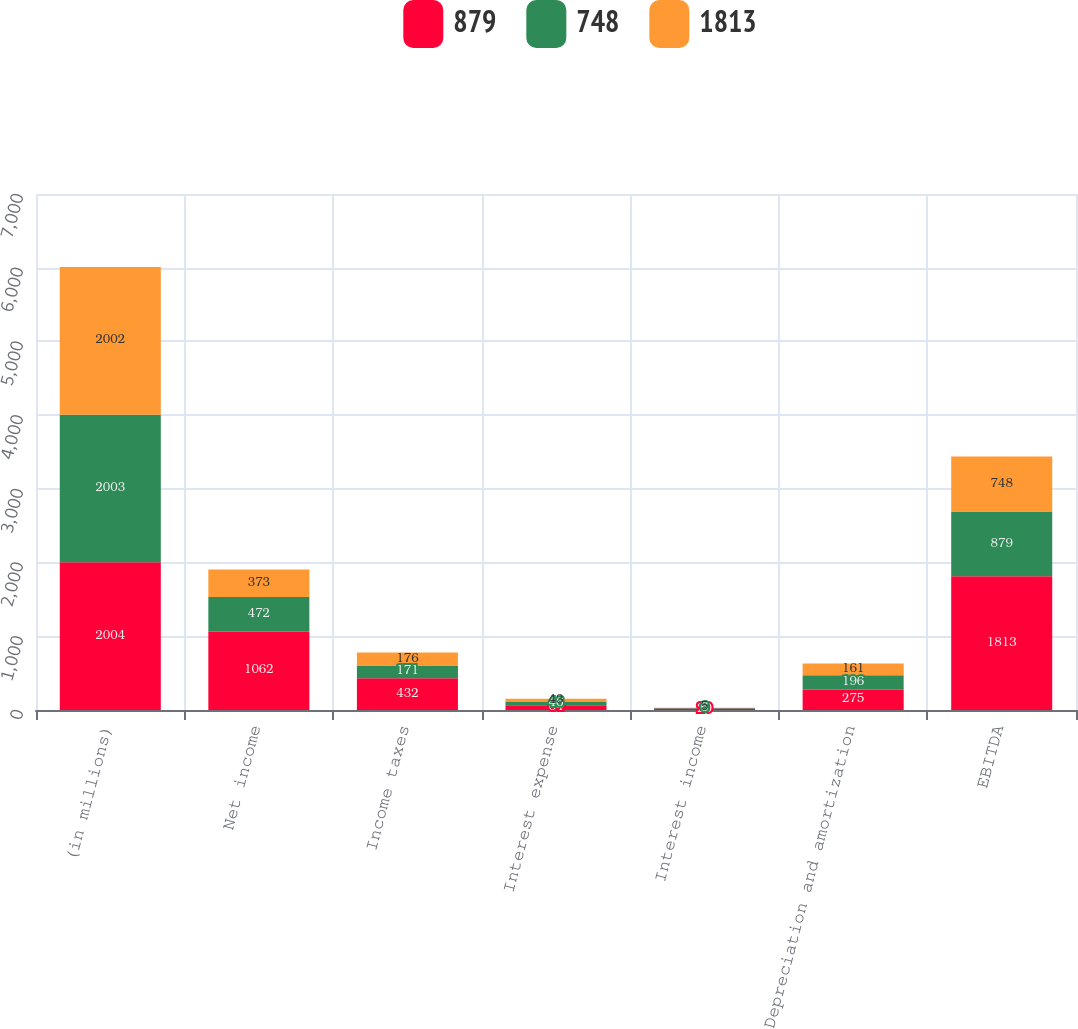Convert chart to OTSL. <chart><loc_0><loc_0><loc_500><loc_500><stacked_bar_chart><ecel><fcel>(in millions)<fcel>Net income<fcel>Income taxes<fcel>Interest expense<fcel>Interest income<fcel>Depreciation and amortization<fcel>EBITDA<nl><fcel>879<fcel>2004<fcel>1062<fcel>432<fcel>64<fcel>20<fcel>275<fcel>1813<nl><fcel>748<fcel>2003<fcel>472<fcel>171<fcel>46<fcel>6<fcel>196<fcel>879<nl><fcel>1813<fcel>2002<fcel>373<fcel>176<fcel>43<fcel>5<fcel>161<fcel>748<nl></chart> 